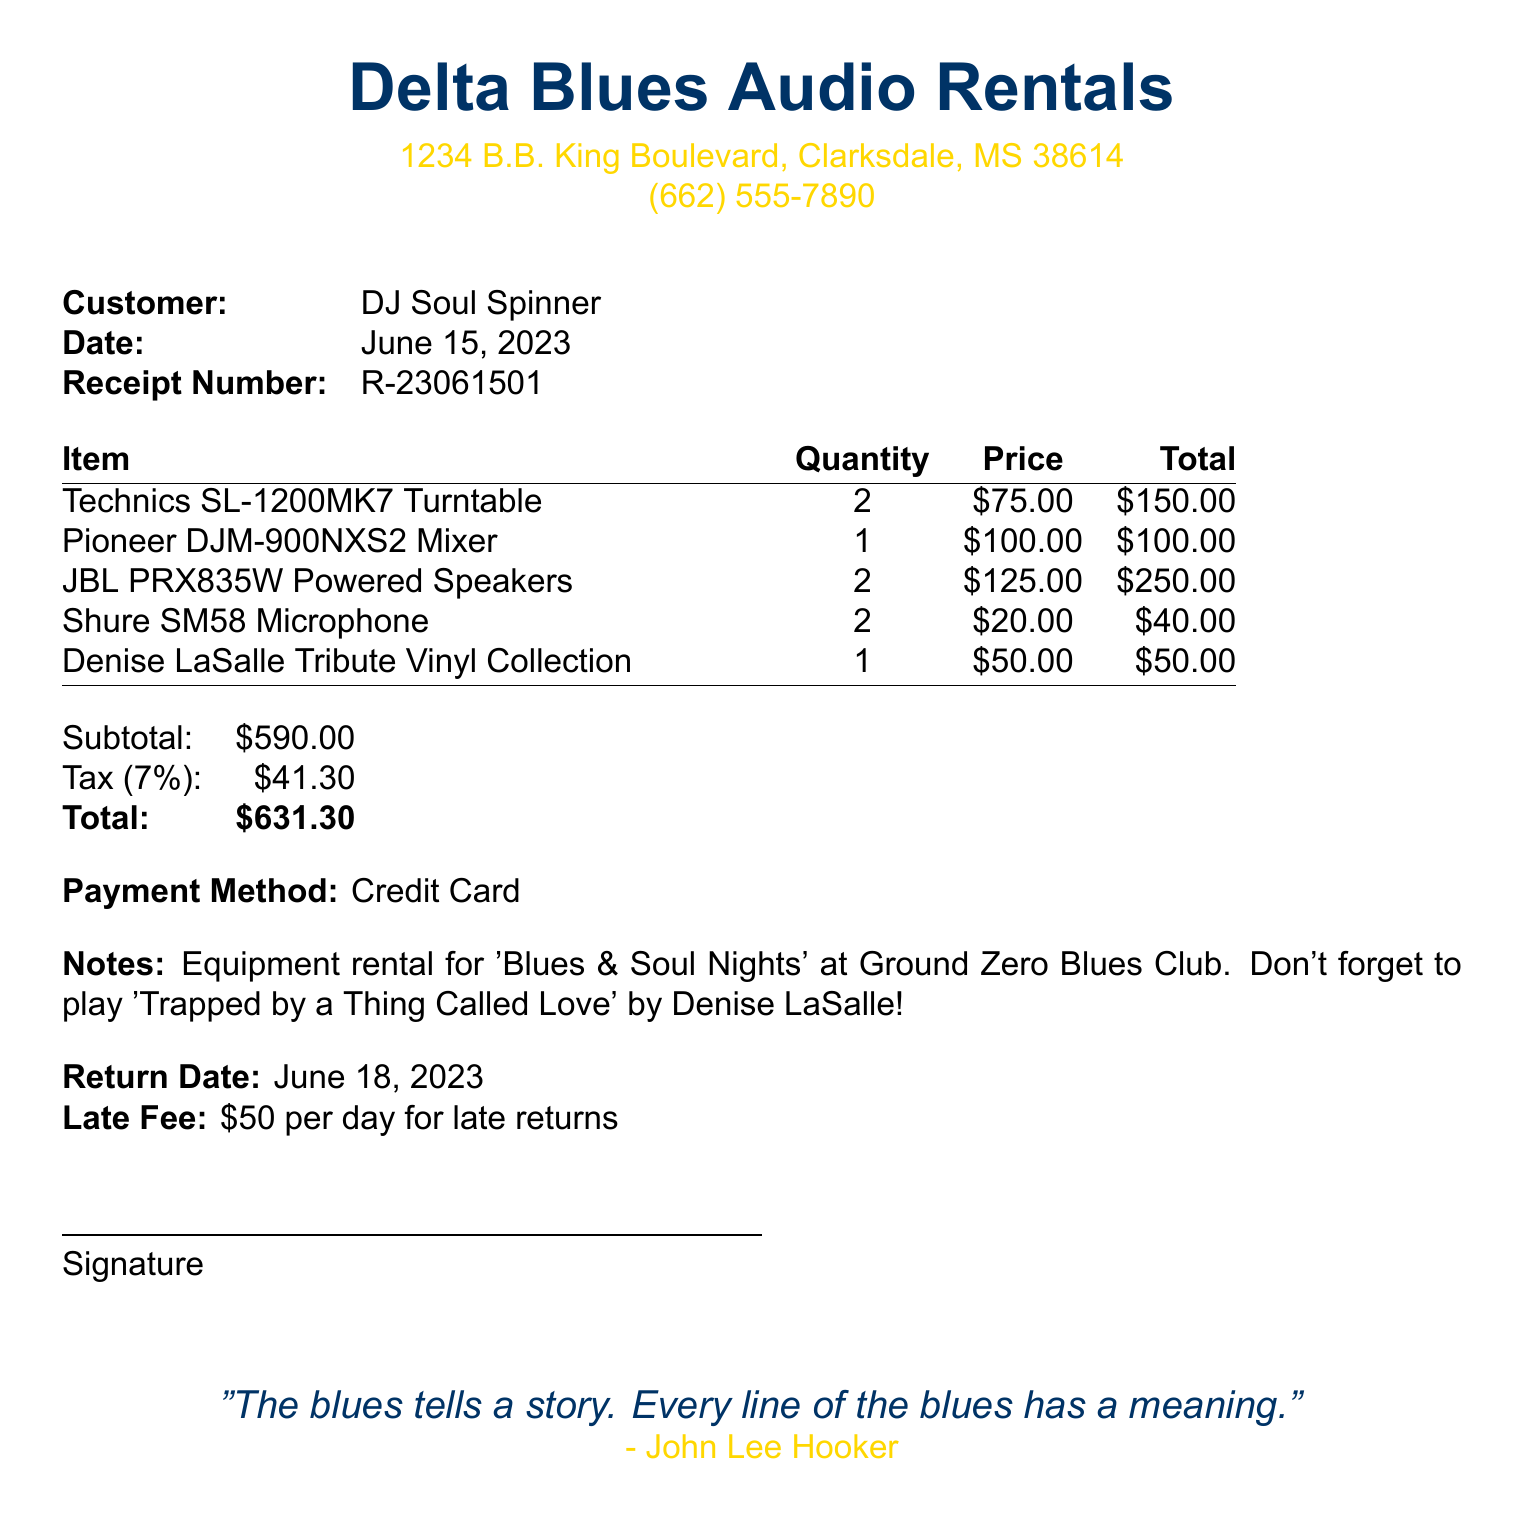What is the business name? The business name is prominently displayed at the top of the receipt.
Answer: Delta Blues Audio Rentals What is the date of the receipt? The date of the receipt is specified next to "Date:".
Answer: June 15, 2023 What is the total amount due? The total amount is located at the bottom of the receipt under the total section.
Answer: $631.30 How many Technics SL-1200MK7 Turntables were rented? The quantity of Technics SL-1200MK7 Turntables rented is listed in the item section.
Answer: 2 What item has a tribute to Denise LaSalle? The item pertaining to Denise LaSalle is explicitly noted in the item list.
Answer: Denise LaSalle Tribute Vinyl Collection What is the late fee amount? The late fee is clearly stated in the notes section of the receipt.
Answer: $50 per day for late returns What is the return date for the rented equipment? The return date is mentioned just before the late fee section.
Answer: June 18, 2023 What payment method was used? The payment method is specified in its own section within the document.
Answer: Credit Card What is the subtotal before tax? The subtotal amount is indicated before the tax is calculated in the financial summary.
Answer: $590.00 